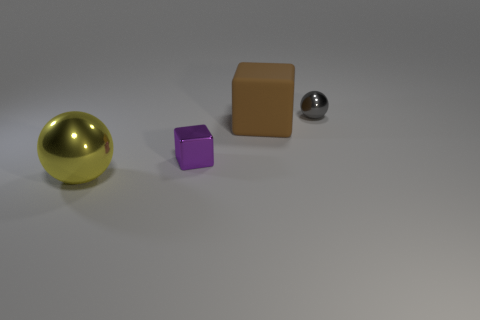Add 4 large balls. How many objects exist? 8 Subtract all purple things. Subtract all large rubber objects. How many objects are left? 2 Add 3 small spheres. How many small spheres are left? 4 Add 2 big matte blocks. How many big matte blocks exist? 3 Subtract 0 blue blocks. How many objects are left? 4 